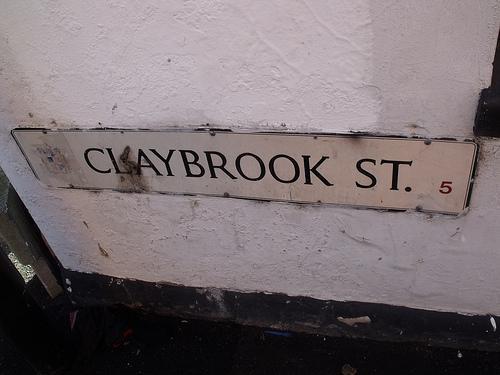How many signs are shown?
Give a very brief answer. 1. 